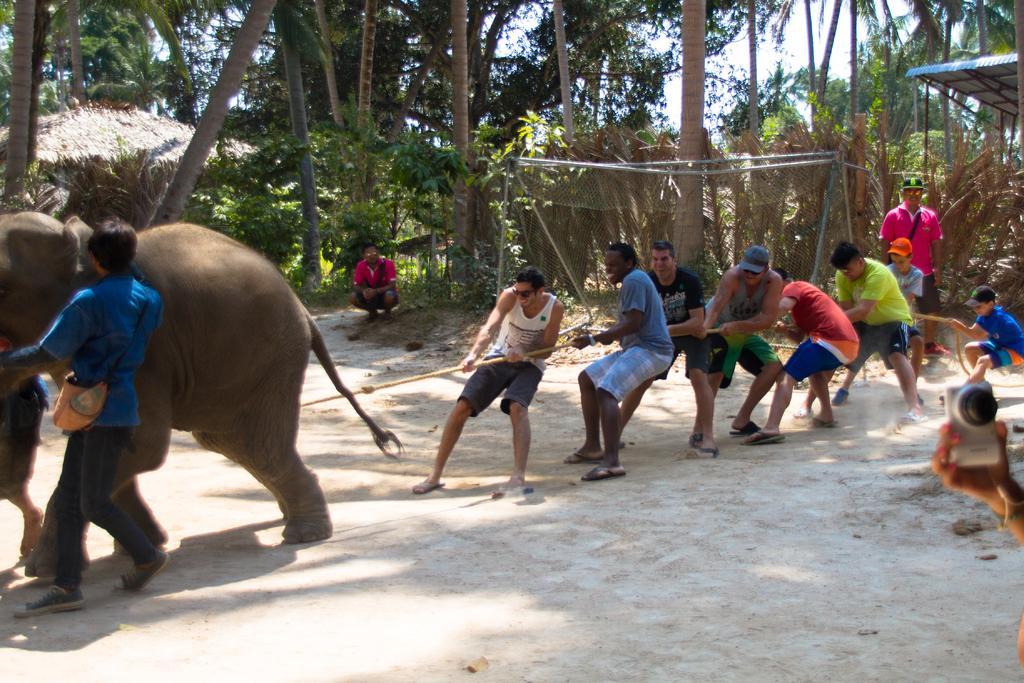How would you summarize this image in a sentence or two? In this image, There are some peoples holding a rope, in the left side of the image there is a person holding a elephant, In the background there are some green color trees. 